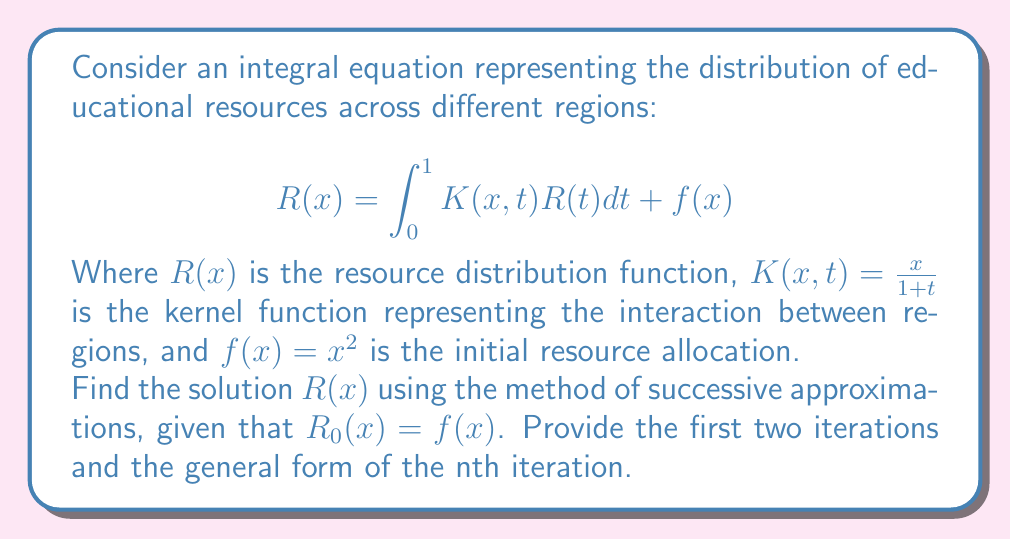Can you answer this question? 1) We start with the initial approximation $R_0(x) = f(x) = x^2$

2) For the first iteration:
   $$R_1(x) = \int_0^1 K(x,t)R_0(t)dt + f(x)$$
   $$= \int_0^1 \frac{x}{1+t}t^2dt + x^2$$
   $$= x\int_0^1 \frac{t^2}{1+t}dt + x^2$$
   
   Let $u = \frac{t^2}{1+t}$, then $du = \frac{2t+t^2}{(1+t)^2}dt$
   
   $$= x[\ln(1+t) - t + \frac{t^2}{2}]_0^1 + x^2$$
   $$= x[\ln(2) - 1 + \frac{1}{2}] + x^2$$
   $$= x(\ln(2) - \frac{1}{2}) + x^2$$

3) For the second iteration:
   $$R_2(x) = \int_0^1 K(x,t)R_1(t)dt + f(x)$$
   $$= \int_0^1 \frac{x}{1+t}[t(\ln(2) - \frac{1}{2}) + t^2]dt + x^2$$
   $$= x\int_0^1 [\frac{t\ln(2)}{1+t} - \frac{t}{2(1+t)} + \frac{t^2}{1+t}]dt + x^2$$
   
   Solving each integral separately and simplifying:
   
   $$= x[(\ln(2))^2 - \frac{\ln(2)}{2} + \frac{1}{4} + (\ln(2) - \frac{3}{4})] + x^2$$
   $$= x[(\ln(2))^2 + \frac{\ln(2)}{2} - \frac{1}{2}] + x^2$$

4) The general form of the nth iteration:
   $$R_n(x) = x[a_n(\ln(2))^n + a_{n-1}(\ln(2))^{n-1} + ... + a_1\ln(2) + a_0] + x^2$$
   
   Where $a_n, a_{n-1}, ..., a_1, a_0$ are constants determined by the recursive process.
Answer: $R_n(x) = x[a_n(\ln(2))^n + a_{n-1}(\ln(2))^{n-1} + ... + a_1\ln(2) + a_0] + x^2$ 